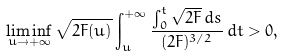<formula> <loc_0><loc_0><loc_500><loc_500>\liminf _ { u \to + \infty } \sqrt { 2 F ( u ) } \int _ { u } ^ { + \infty } \frac { \int _ { 0 } ^ { t } \sqrt { 2 F } \, d s } { ( 2 F ) ^ { 3 / 2 } } \, d t > 0 ,</formula> 